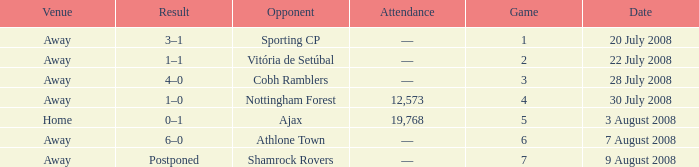What is the total game number with athlone town as the opponent? 1.0. 